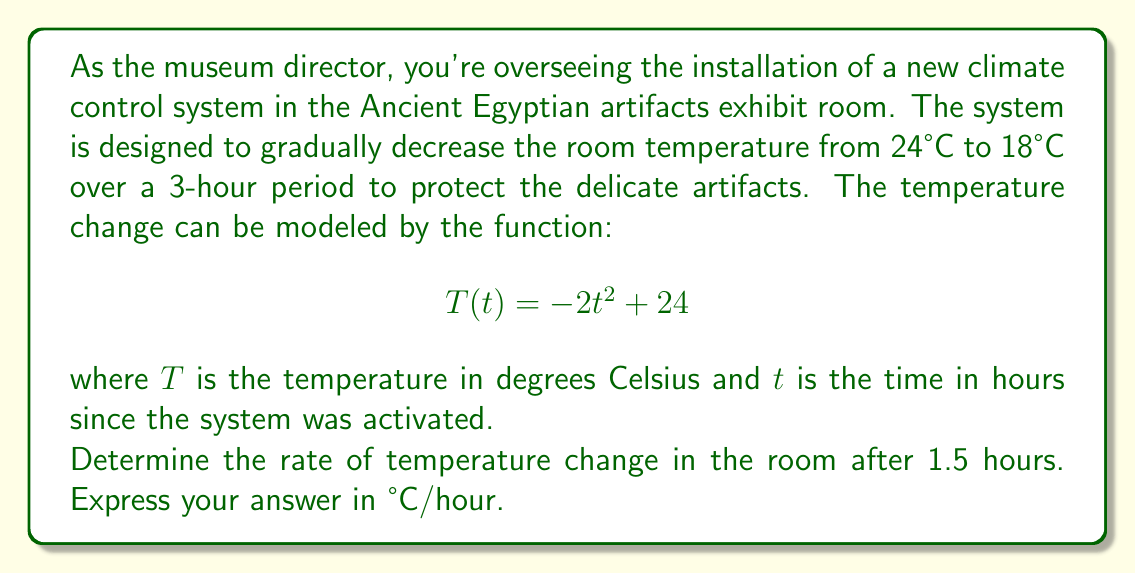Solve this math problem. To solve this problem, we need to find the instantaneous rate of change of the temperature function at $t = 1.5$ hours. This is equivalent to finding the derivative of the function $T(t)$ and evaluating it at $t = 1.5$.

1. Given function: $T(t) = -2t^2 + 24$

2. Find the derivative of $T(t)$:
   $$\frac{dT}{dt} = \frac{d}{dt}(-2t^2 + 24) = -4t$$

3. The derivative $\frac{dT}{dt}$ represents the rate of change of temperature with respect to time.

4. Evaluate $\frac{dT}{dt}$ at $t = 1.5$:
   $$\frac{dT}{dt}\bigg|_{t=1.5} = -4(1.5) = -6$$

5. Interpret the result:
   The negative sign indicates that the temperature is decreasing.
   The rate of change is 6°C per hour.

Therefore, after 1.5 hours, the temperature in the exhibit room is decreasing at a rate of 6°C per hour.
Answer: $-6$ °C/hour 